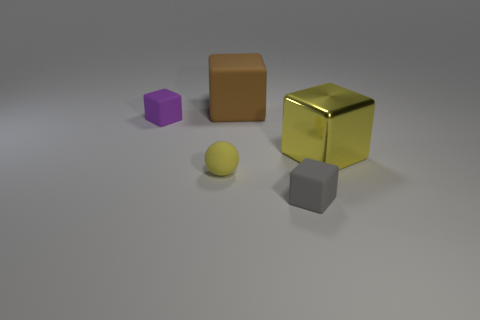There is a thing that is the same color as the rubber sphere; what is its size?
Offer a very short reply. Large. How many large yellow balls have the same material as the large brown thing?
Give a very brief answer. 0. Do the big metallic block and the small matte sphere in front of the large yellow thing have the same color?
Your response must be concise. Yes. What number of small yellow balls are there?
Your response must be concise. 1. Is there a rubber cylinder that has the same color as the tiny matte ball?
Give a very brief answer. No. There is a object that is to the right of the small cube to the right of the tiny rubber cube behind the tiny gray matte cube; what is its color?
Give a very brief answer. Yellow. Is the material of the large brown cube the same as the yellow thing that is right of the small ball?
Your answer should be very brief. No. What is the large yellow cube made of?
Make the answer very short. Metal. There is a small ball that is the same color as the large shiny block; what is it made of?
Your answer should be compact. Rubber. What number of other objects are there of the same material as the big yellow thing?
Provide a succinct answer. 0. 